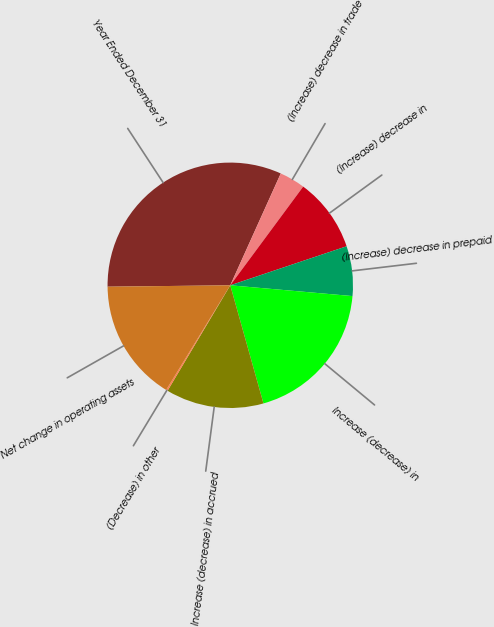Convert chart. <chart><loc_0><loc_0><loc_500><loc_500><pie_chart><fcel>Year Ended December 31<fcel>(Increase) decrease in trade<fcel>(Increase) decrease in<fcel>(Increase) decrease in prepaid<fcel>Increase (decrease) in<fcel>Increase (decrease) in accrued<fcel>(Decrease) in other<fcel>Net change in operating assets<nl><fcel>31.93%<fcel>3.38%<fcel>9.72%<fcel>6.55%<fcel>19.24%<fcel>12.9%<fcel>0.21%<fcel>16.07%<nl></chart> 